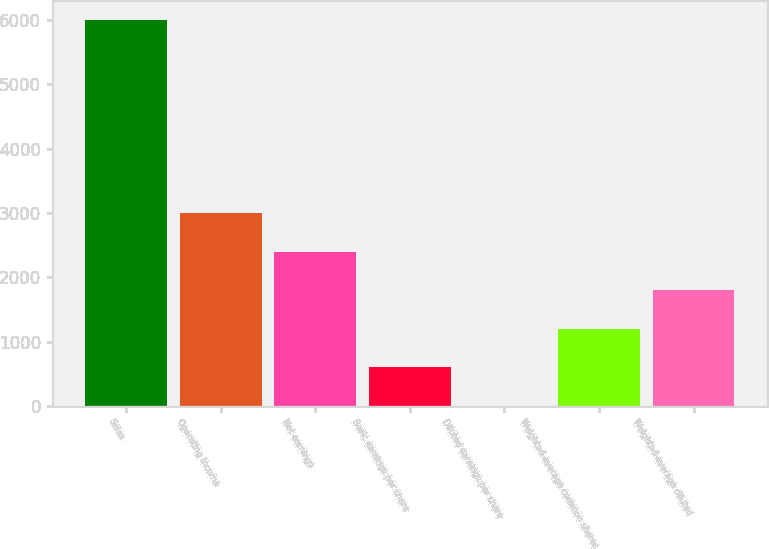<chart> <loc_0><loc_0><loc_500><loc_500><bar_chart><fcel>Sales<fcel>Operating income<fcel>Net earnings<fcel>Basic earnings per share<fcel>Diluted earnings per share<fcel>Weighted-average common shares<fcel>Weighted-average diluted<nl><fcel>6000<fcel>3001.43<fcel>2401.72<fcel>602.57<fcel>2.85<fcel>1202.29<fcel>1802.01<nl></chart> 